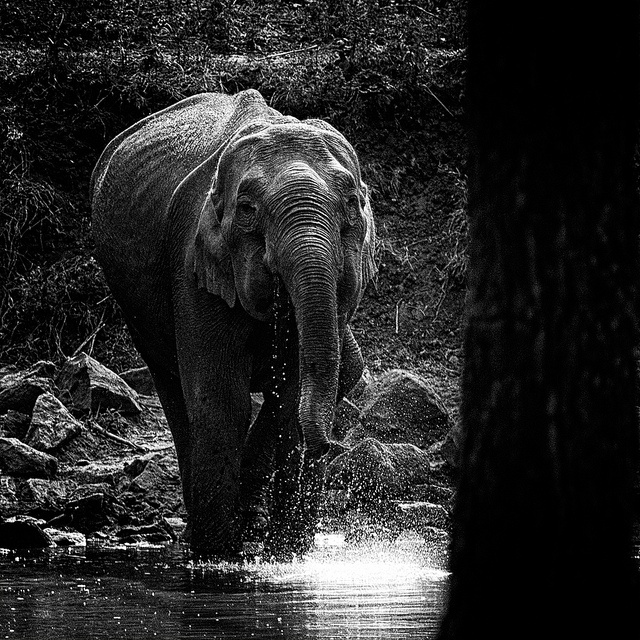Describe the objects in this image and their specific colors. I can see a elephant in black, gray, darkgray, and lightgray tones in this image. 